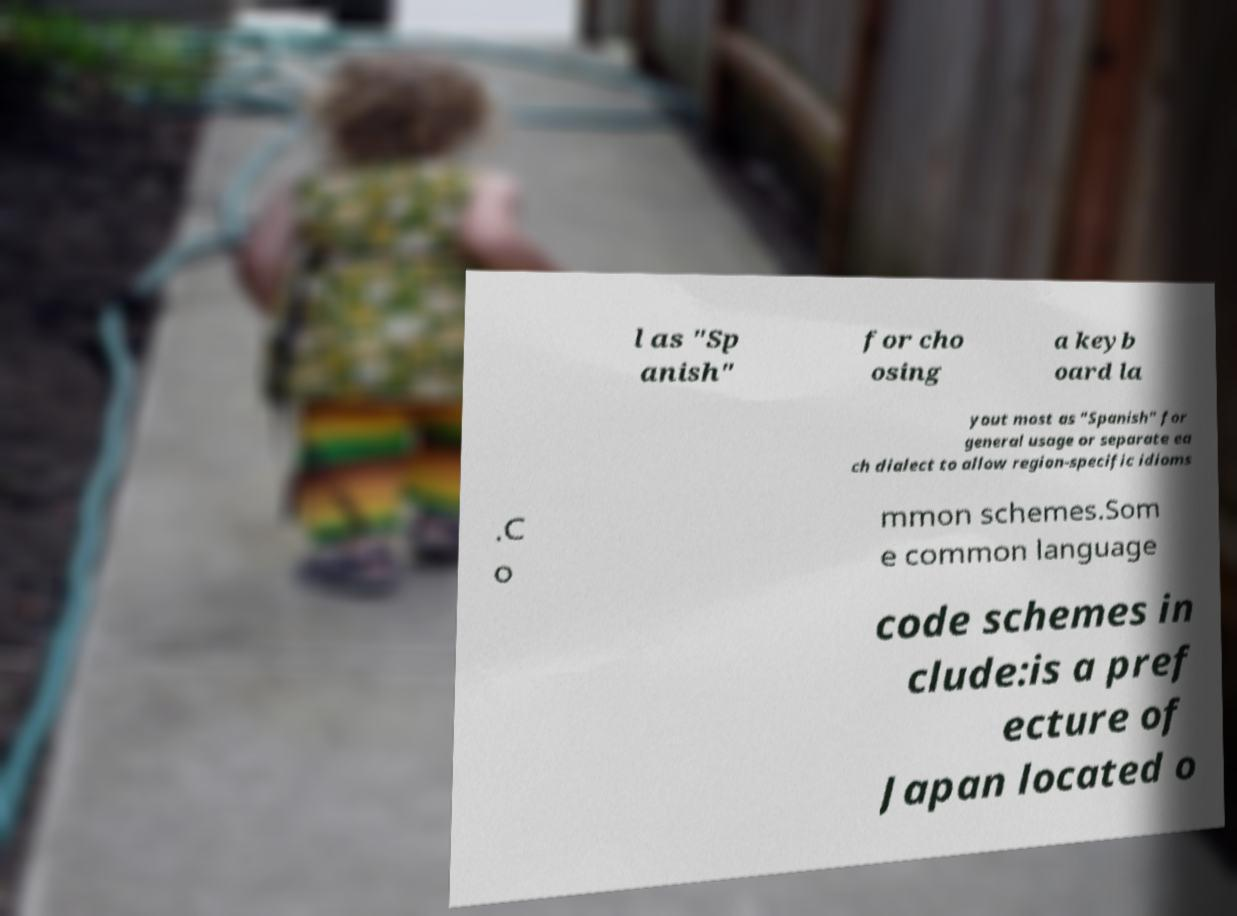Can you read and provide the text displayed in the image?This photo seems to have some interesting text. Can you extract and type it out for me? l as "Sp anish" for cho osing a keyb oard la yout most as "Spanish" for general usage or separate ea ch dialect to allow region-specific idioms .C o mmon schemes.Som e common language code schemes in clude:is a pref ecture of Japan located o 